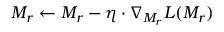<formula> <loc_0><loc_0><loc_500><loc_500>M _ { r } \leftarrow M _ { r } - \eta \cdot \nabla _ { M _ { r } } L ( M _ { r } )</formula> 